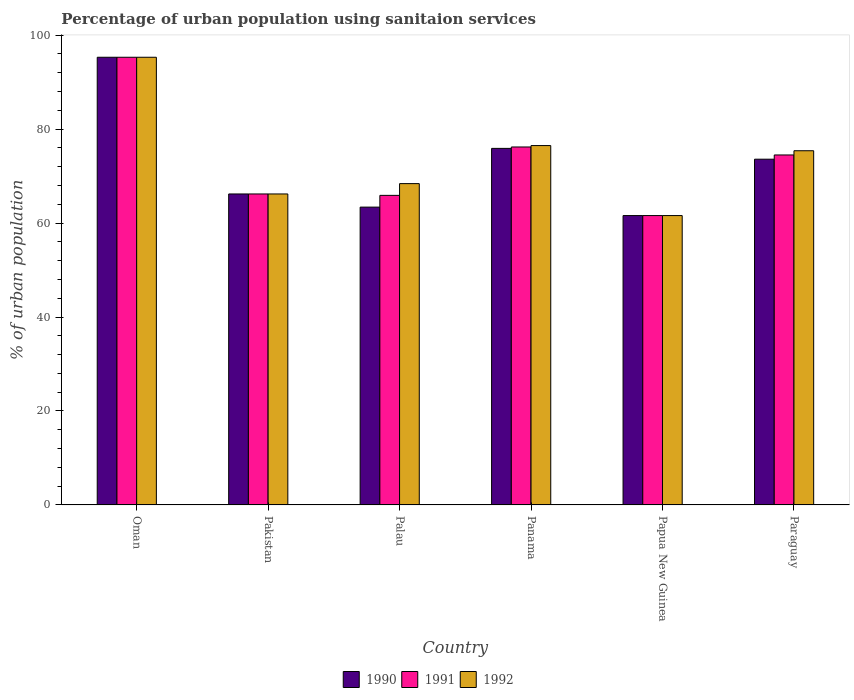How many groups of bars are there?
Ensure brevity in your answer.  6. Are the number of bars per tick equal to the number of legend labels?
Offer a very short reply. Yes. Are the number of bars on each tick of the X-axis equal?
Provide a succinct answer. Yes. What is the label of the 6th group of bars from the left?
Make the answer very short. Paraguay. What is the percentage of urban population using sanitaion services in 1990 in Pakistan?
Offer a terse response. 66.2. Across all countries, what is the maximum percentage of urban population using sanitaion services in 1991?
Offer a very short reply. 95.3. Across all countries, what is the minimum percentage of urban population using sanitaion services in 1991?
Give a very brief answer. 61.6. In which country was the percentage of urban population using sanitaion services in 1991 maximum?
Provide a short and direct response. Oman. In which country was the percentage of urban population using sanitaion services in 1991 minimum?
Provide a succinct answer. Papua New Guinea. What is the total percentage of urban population using sanitaion services in 1990 in the graph?
Ensure brevity in your answer.  436. What is the difference between the percentage of urban population using sanitaion services in 1990 in Palau and that in Paraguay?
Give a very brief answer. -10.2. What is the difference between the percentage of urban population using sanitaion services in 1992 in Papua New Guinea and the percentage of urban population using sanitaion services in 1991 in Palau?
Offer a very short reply. -4.3. What is the average percentage of urban population using sanitaion services in 1990 per country?
Provide a succinct answer. 72.67. What is the difference between the percentage of urban population using sanitaion services of/in 1990 and percentage of urban population using sanitaion services of/in 1991 in Palau?
Your response must be concise. -2.5. In how many countries, is the percentage of urban population using sanitaion services in 1992 greater than 80 %?
Your response must be concise. 1. What is the ratio of the percentage of urban population using sanitaion services in 1992 in Oman to that in Palau?
Provide a short and direct response. 1.39. Is the difference between the percentage of urban population using sanitaion services in 1990 in Oman and Panama greater than the difference between the percentage of urban population using sanitaion services in 1991 in Oman and Panama?
Your response must be concise. Yes. What is the difference between the highest and the second highest percentage of urban population using sanitaion services in 1991?
Provide a succinct answer. -1.7. What is the difference between the highest and the lowest percentage of urban population using sanitaion services in 1991?
Your answer should be very brief. 33.7. In how many countries, is the percentage of urban population using sanitaion services in 1990 greater than the average percentage of urban population using sanitaion services in 1990 taken over all countries?
Keep it short and to the point. 3. What does the 1st bar from the left in Pakistan represents?
Your response must be concise. 1990. Is it the case that in every country, the sum of the percentage of urban population using sanitaion services in 1991 and percentage of urban population using sanitaion services in 1990 is greater than the percentage of urban population using sanitaion services in 1992?
Your answer should be compact. Yes. How many countries are there in the graph?
Your answer should be compact. 6. What is the difference between two consecutive major ticks on the Y-axis?
Offer a terse response. 20. Are the values on the major ticks of Y-axis written in scientific E-notation?
Your answer should be very brief. No. Does the graph contain any zero values?
Keep it short and to the point. No. Where does the legend appear in the graph?
Keep it short and to the point. Bottom center. How many legend labels are there?
Your answer should be compact. 3. How are the legend labels stacked?
Ensure brevity in your answer.  Horizontal. What is the title of the graph?
Offer a terse response. Percentage of urban population using sanitaion services. What is the label or title of the Y-axis?
Offer a very short reply. % of urban population. What is the % of urban population in 1990 in Oman?
Provide a short and direct response. 95.3. What is the % of urban population of 1991 in Oman?
Keep it short and to the point. 95.3. What is the % of urban population in 1992 in Oman?
Offer a terse response. 95.3. What is the % of urban population in 1990 in Pakistan?
Offer a terse response. 66.2. What is the % of urban population of 1991 in Pakistan?
Your response must be concise. 66.2. What is the % of urban population in 1992 in Pakistan?
Give a very brief answer. 66.2. What is the % of urban population in 1990 in Palau?
Your answer should be very brief. 63.4. What is the % of urban population of 1991 in Palau?
Offer a very short reply. 65.9. What is the % of urban population of 1992 in Palau?
Provide a succinct answer. 68.4. What is the % of urban population of 1990 in Panama?
Provide a succinct answer. 75.9. What is the % of urban population in 1991 in Panama?
Your response must be concise. 76.2. What is the % of urban population in 1992 in Panama?
Your answer should be very brief. 76.5. What is the % of urban population of 1990 in Papua New Guinea?
Make the answer very short. 61.6. What is the % of urban population of 1991 in Papua New Guinea?
Make the answer very short. 61.6. What is the % of urban population in 1992 in Papua New Guinea?
Ensure brevity in your answer.  61.6. What is the % of urban population of 1990 in Paraguay?
Your response must be concise. 73.6. What is the % of urban population of 1991 in Paraguay?
Make the answer very short. 74.5. What is the % of urban population of 1992 in Paraguay?
Provide a succinct answer. 75.4. Across all countries, what is the maximum % of urban population in 1990?
Ensure brevity in your answer.  95.3. Across all countries, what is the maximum % of urban population of 1991?
Your response must be concise. 95.3. Across all countries, what is the maximum % of urban population in 1992?
Give a very brief answer. 95.3. Across all countries, what is the minimum % of urban population in 1990?
Offer a terse response. 61.6. Across all countries, what is the minimum % of urban population of 1991?
Keep it short and to the point. 61.6. Across all countries, what is the minimum % of urban population of 1992?
Provide a short and direct response. 61.6. What is the total % of urban population in 1990 in the graph?
Your answer should be compact. 436. What is the total % of urban population in 1991 in the graph?
Offer a very short reply. 439.7. What is the total % of urban population in 1992 in the graph?
Your answer should be very brief. 443.4. What is the difference between the % of urban population in 1990 in Oman and that in Pakistan?
Make the answer very short. 29.1. What is the difference between the % of urban population in 1991 in Oman and that in Pakistan?
Keep it short and to the point. 29.1. What is the difference between the % of urban population in 1992 in Oman and that in Pakistan?
Ensure brevity in your answer.  29.1. What is the difference between the % of urban population in 1990 in Oman and that in Palau?
Offer a terse response. 31.9. What is the difference between the % of urban population in 1991 in Oman and that in Palau?
Offer a very short reply. 29.4. What is the difference between the % of urban population of 1992 in Oman and that in Palau?
Keep it short and to the point. 26.9. What is the difference between the % of urban population in 1990 in Oman and that in Panama?
Make the answer very short. 19.4. What is the difference between the % of urban population of 1991 in Oman and that in Panama?
Your answer should be compact. 19.1. What is the difference between the % of urban population of 1990 in Oman and that in Papua New Guinea?
Your answer should be compact. 33.7. What is the difference between the % of urban population of 1991 in Oman and that in Papua New Guinea?
Keep it short and to the point. 33.7. What is the difference between the % of urban population of 1992 in Oman and that in Papua New Guinea?
Your answer should be compact. 33.7. What is the difference between the % of urban population of 1990 in Oman and that in Paraguay?
Make the answer very short. 21.7. What is the difference between the % of urban population of 1991 in Oman and that in Paraguay?
Ensure brevity in your answer.  20.8. What is the difference between the % of urban population of 1990 in Pakistan and that in Panama?
Your response must be concise. -9.7. What is the difference between the % of urban population in 1991 in Pakistan and that in Panama?
Make the answer very short. -10. What is the difference between the % of urban population of 1990 in Pakistan and that in Papua New Guinea?
Your response must be concise. 4.6. What is the difference between the % of urban population of 1991 in Pakistan and that in Papua New Guinea?
Give a very brief answer. 4.6. What is the difference between the % of urban population of 1992 in Pakistan and that in Papua New Guinea?
Offer a terse response. 4.6. What is the difference between the % of urban population of 1992 in Pakistan and that in Paraguay?
Make the answer very short. -9.2. What is the difference between the % of urban population in 1990 in Palau and that in Panama?
Keep it short and to the point. -12.5. What is the difference between the % of urban population in 1992 in Palau and that in Panama?
Make the answer very short. -8.1. What is the difference between the % of urban population of 1991 in Palau and that in Paraguay?
Provide a succinct answer. -8.6. What is the difference between the % of urban population of 1992 in Palau and that in Paraguay?
Keep it short and to the point. -7. What is the difference between the % of urban population of 1990 in Panama and that in Paraguay?
Your answer should be very brief. 2.3. What is the difference between the % of urban population in 1990 in Papua New Guinea and that in Paraguay?
Offer a very short reply. -12. What is the difference between the % of urban population in 1991 in Papua New Guinea and that in Paraguay?
Ensure brevity in your answer.  -12.9. What is the difference between the % of urban population in 1992 in Papua New Guinea and that in Paraguay?
Keep it short and to the point. -13.8. What is the difference between the % of urban population of 1990 in Oman and the % of urban population of 1991 in Pakistan?
Your response must be concise. 29.1. What is the difference between the % of urban population of 1990 in Oman and the % of urban population of 1992 in Pakistan?
Offer a terse response. 29.1. What is the difference between the % of urban population in 1991 in Oman and the % of urban population in 1992 in Pakistan?
Offer a terse response. 29.1. What is the difference between the % of urban population in 1990 in Oman and the % of urban population in 1991 in Palau?
Offer a terse response. 29.4. What is the difference between the % of urban population of 1990 in Oman and the % of urban population of 1992 in Palau?
Offer a terse response. 26.9. What is the difference between the % of urban population in 1991 in Oman and the % of urban population in 1992 in Palau?
Offer a very short reply. 26.9. What is the difference between the % of urban population of 1990 in Oman and the % of urban population of 1991 in Panama?
Give a very brief answer. 19.1. What is the difference between the % of urban population in 1991 in Oman and the % of urban population in 1992 in Panama?
Your answer should be very brief. 18.8. What is the difference between the % of urban population of 1990 in Oman and the % of urban population of 1991 in Papua New Guinea?
Offer a very short reply. 33.7. What is the difference between the % of urban population in 1990 in Oman and the % of urban population in 1992 in Papua New Guinea?
Give a very brief answer. 33.7. What is the difference between the % of urban population in 1991 in Oman and the % of urban population in 1992 in Papua New Guinea?
Keep it short and to the point. 33.7. What is the difference between the % of urban population of 1990 in Oman and the % of urban population of 1991 in Paraguay?
Provide a succinct answer. 20.8. What is the difference between the % of urban population of 1990 in Oman and the % of urban population of 1992 in Paraguay?
Give a very brief answer. 19.9. What is the difference between the % of urban population in 1991 in Oman and the % of urban population in 1992 in Paraguay?
Offer a terse response. 19.9. What is the difference between the % of urban population of 1990 in Pakistan and the % of urban population of 1991 in Palau?
Your answer should be very brief. 0.3. What is the difference between the % of urban population of 1990 in Pakistan and the % of urban population of 1992 in Palau?
Offer a terse response. -2.2. What is the difference between the % of urban population of 1991 in Pakistan and the % of urban population of 1992 in Palau?
Keep it short and to the point. -2.2. What is the difference between the % of urban population in 1990 in Pakistan and the % of urban population in 1991 in Panama?
Give a very brief answer. -10. What is the difference between the % of urban population in 1990 in Pakistan and the % of urban population in 1992 in Papua New Guinea?
Give a very brief answer. 4.6. What is the difference between the % of urban population in 1990 in Pakistan and the % of urban population in 1992 in Paraguay?
Your answer should be very brief. -9.2. What is the difference between the % of urban population of 1990 in Palau and the % of urban population of 1991 in Panama?
Your response must be concise. -12.8. What is the difference between the % of urban population of 1990 in Palau and the % of urban population of 1992 in Panama?
Your answer should be very brief. -13.1. What is the difference between the % of urban population of 1990 in Palau and the % of urban population of 1991 in Papua New Guinea?
Give a very brief answer. 1.8. What is the difference between the % of urban population in 1991 in Palau and the % of urban population in 1992 in Papua New Guinea?
Provide a short and direct response. 4.3. What is the difference between the % of urban population in 1990 in Palau and the % of urban population in 1992 in Paraguay?
Your response must be concise. -12. What is the difference between the % of urban population in 1991 in Palau and the % of urban population in 1992 in Paraguay?
Offer a terse response. -9.5. What is the difference between the % of urban population in 1990 in Panama and the % of urban population in 1991 in Papua New Guinea?
Provide a succinct answer. 14.3. What is the difference between the % of urban population in 1990 in Panama and the % of urban population in 1992 in Papua New Guinea?
Your answer should be compact. 14.3. What is the difference between the % of urban population of 1991 in Panama and the % of urban population of 1992 in Papua New Guinea?
Offer a very short reply. 14.6. What is the difference between the % of urban population of 1990 in Panama and the % of urban population of 1991 in Paraguay?
Your response must be concise. 1.4. What is the difference between the % of urban population in 1990 in Panama and the % of urban population in 1992 in Paraguay?
Offer a very short reply. 0.5. What is the difference between the % of urban population in 1990 in Papua New Guinea and the % of urban population in 1991 in Paraguay?
Keep it short and to the point. -12.9. What is the difference between the % of urban population in 1990 in Papua New Guinea and the % of urban population in 1992 in Paraguay?
Your answer should be compact. -13.8. What is the average % of urban population in 1990 per country?
Your response must be concise. 72.67. What is the average % of urban population in 1991 per country?
Your answer should be compact. 73.28. What is the average % of urban population of 1992 per country?
Offer a very short reply. 73.9. What is the difference between the % of urban population in 1990 and % of urban population in 1991 in Oman?
Offer a terse response. 0. What is the difference between the % of urban population of 1990 and % of urban population of 1992 in Oman?
Offer a terse response. 0. What is the difference between the % of urban population of 1990 and % of urban population of 1992 in Pakistan?
Ensure brevity in your answer.  0. What is the difference between the % of urban population of 1991 and % of urban population of 1992 in Pakistan?
Provide a short and direct response. 0. What is the difference between the % of urban population of 1990 and % of urban population of 1991 in Palau?
Your answer should be compact. -2.5. What is the difference between the % of urban population of 1990 and % of urban population of 1992 in Palau?
Offer a very short reply. -5. What is the difference between the % of urban population in 1990 and % of urban population in 1992 in Panama?
Keep it short and to the point. -0.6. What is the difference between the % of urban population of 1990 and % of urban population of 1992 in Papua New Guinea?
Provide a short and direct response. 0. What is the difference between the % of urban population of 1990 and % of urban population of 1991 in Paraguay?
Your answer should be very brief. -0.9. What is the difference between the % of urban population in 1990 and % of urban population in 1992 in Paraguay?
Your response must be concise. -1.8. What is the ratio of the % of urban population in 1990 in Oman to that in Pakistan?
Ensure brevity in your answer.  1.44. What is the ratio of the % of urban population of 1991 in Oman to that in Pakistan?
Offer a very short reply. 1.44. What is the ratio of the % of urban population of 1992 in Oman to that in Pakistan?
Make the answer very short. 1.44. What is the ratio of the % of urban population in 1990 in Oman to that in Palau?
Ensure brevity in your answer.  1.5. What is the ratio of the % of urban population of 1991 in Oman to that in Palau?
Ensure brevity in your answer.  1.45. What is the ratio of the % of urban population in 1992 in Oman to that in Palau?
Offer a terse response. 1.39. What is the ratio of the % of urban population in 1990 in Oman to that in Panama?
Your answer should be very brief. 1.26. What is the ratio of the % of urban population of 1991 in Oman to that in Panama?
Your response must be concise. 1.25. What is the ratio of the % of urban population in 1992 in Oman to that in Panama?
Ensure brevity in your answer.  1.25. What is the ratio of the % of urban population of 1990 in Oman to that in Papua New Guinea?
Ensure brevity in your answer.  1.55. What is the ratio of the % of urban population of 1991 in Oman to that in Papua New Guinea?
Your answer should be very brief. 1.55. What is the ratio of the % of urban population in 1992 in Oman to that in Papua New Guinea?
Ensure brevity in your answer.  1.55. What is the ratio of the % of urban population in 1990 in Oman to that in Paraguay?
Give a very brief answer. 1.29. What is the ratio of the % of urban population in 1991 in Oman to that in Paraguay?
Your response must be concise. 1.28. What is the ratio of the % of urban population of 1992 in Oman to that in Paraguay?
Ensure brevity in your answer.  1.26. What is the ratio of the % of urban population of 1990 in Pakistan to that in Palau?
Give a very brief answer. 1.04. What is the ratio of the % of urban population in 1992 in Pakistan to that in Palau?
Make the answer very short. 0.97. What is the ratio of the % of urban population in 1990 in Pakistan to that in Panama?
Give a very brief answer. 0.87. What is the ratio of the % of urban population of 1991 in Pakistan to that in Panama?
Give a very brief answer. 0.87. What is the ratio of the % of urban population in 1992 in Pakistan to that in Panama?
Offer a very short reply. 0.87. What is the ratio of the % of urban population in 1990 in Pakistan to that in Papua New Guinea?
Keep it short and to the point. 1.07. What is the ratio of the % of urban population of 1991 in Pakistan to that in Papua New Guinea?
Your response must be concise. 1.07. What is the ratio of the % of urban population in 1992 in Pakistan to that in Papua New Guinea?
Keep it short and to the point. 1.07. What is the ratio of the % of urban population in 1990 in Pakistan to that in Paraguay?
Keep it short and to the point. 0.9. What is the ratio of the % of urban population in 1991 in Pakistan to that in Paraguay?
Provide a succinct answer. 0.89. What is the ratio of the % of urban population in 1992 in Pakistan to that in Paraguay?
Make the answer very short. 0.88. What is the ratio of the % of urban population in 1990 in Palau to that in Panama?
Offer a very short reply. 0.84. What is the ratio of the % of urban population of 1991 in Palau to that in Panama?
Provide a succinct answer. 0.86. What is the ratio of the % of urban population of 1992 in Palau to that in Panama?
Give a very brief answer. 0.89. What is the ratio of the % of urban population in 1990 in Palau to that in Papua New Guinea?
Ensure brevity in your answer.  1.03. What is the ratio of the % of urban population in 1991 in Palau to that in Papua New Guinea?
Keep it short and to the point. 1.07. What is the ratio of the % of urban population of 1992 in Palau to that in Papua New Guinea?
Your answer should be very brief. 1.11. What is the ratio of the % of urban population in 1990 in Palau to that in Paraguay?
Make the answer very short. 0.86. What is the ratio of the % of urban population in 1991 in Palau to that in Paraguay?
Your answer should be very brief. 0.88. What is the ratio of the % of urban population in 1992 in Palau to that in Paraguay?
Give a very brief answer. 0.91. What is the ratio of the % of urban population of 1990 in Panama to that in Papua New Guinea?
Ensure brevity in your answer.  1.23. What is the ratio of the % of urban population in 1991 in Panama to that in Papua New Guinea?
Offer a terse response. 1.24. What is the ratio of the % of urban population in 1992 in Panama to that in Papua New Guinea?
Keep it short and to the point. 1.24. What is the ratio of the % of urban population of 1990 in Panama to that in Paraguay?
Offer a very short reply. 1.03. What is the ratio of the % of urban population of 1991 in Panama to that in Paraguay?
Make the answer very short. 1.02. What is the ratio of the % of urban population of 1992 in Panama to that in Paraguay?
Your answer should be very brief. 1.01. What is the ratio of the % of urban population in 1990 in Papua New Guinea to that in Paraguay?
Give a very brief answer. 0.84. What is the ratio of the % of urban population of 1991 in Papua New Guinea to that in Paraguay?
Provide a short and direct response. 0.83. What is the ratio of the % of urban population in 1992 in Papua New Guinea to that in Paraguay?
Offer a terse response. 0.82. What is the difference between the highest and the second highest % of urban population in 1991?
Offer a terse response. 19.1. What is the difference between the highest and the second highest % of urban population in 1992?
Provide a succinct answer. 18.8. What is the difference between the highest and the lowest % of urban population of 1990?
Offer a very short reply. 33.7. What is the difference between the highest and the lowest % of urban population of 1991?
Keep it short and to the point. 33.7. What is the difference between the highest and the lowest % of urban population of 1992?
Ensure brevity in your answer.  33.7. 